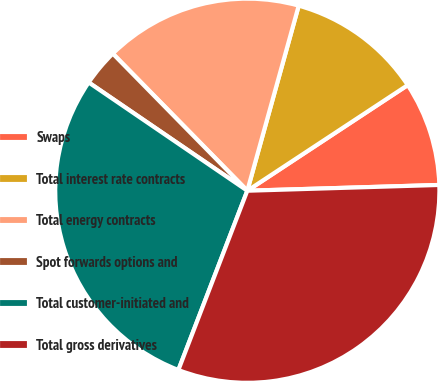<chart> <loc_0><loc_0><loc_500><loc_500><pie_chart><fcel>Swaps<fcel>Total interest rate contracts<fcel>Total energy contracts<fcel>Spot forwards options and<fcel>Total customer-initiated and<fcel>Total gross derivatives<nl><fcel>8.79%<fcel>11.42%<fcel>16.66%<fcel>3.12%<fcel>28.69%<fcel>31.32%<nl></chart> 